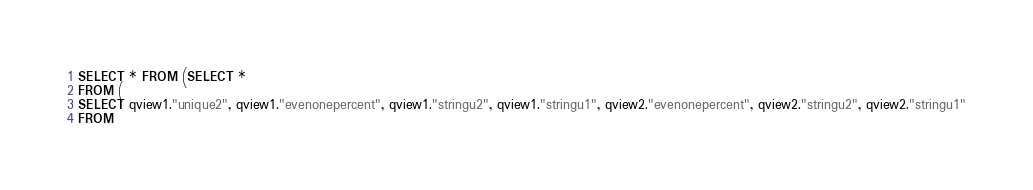<code> <loc_0><loc_0><loc_500><loc_500><_SQL_>SELECT * FROM (SELECT *
FROM (
SELECT qview1."unique2", qview1."evenonepercent", qview1."stringu2", qview1."stringu1", qview2."evenonepercent", qview2."stringu2", qview2."stringu1"
FROM</code> 